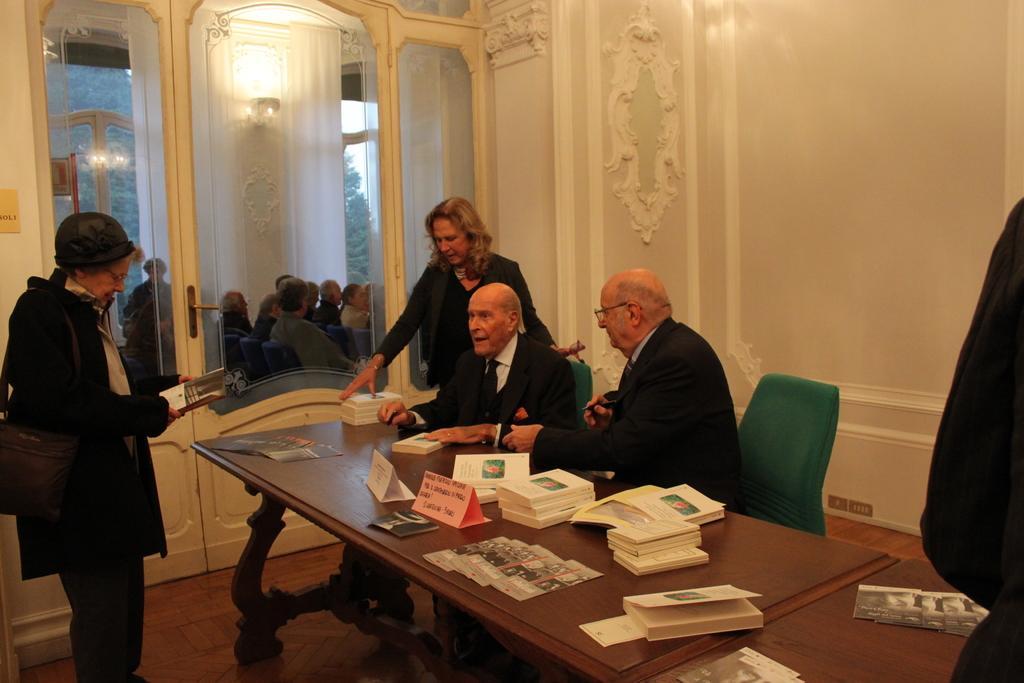Can you describe this image briefly? As we can see in the image, there is a wall, door, two people sitting on chairs, a table. On table there are books and poster. 